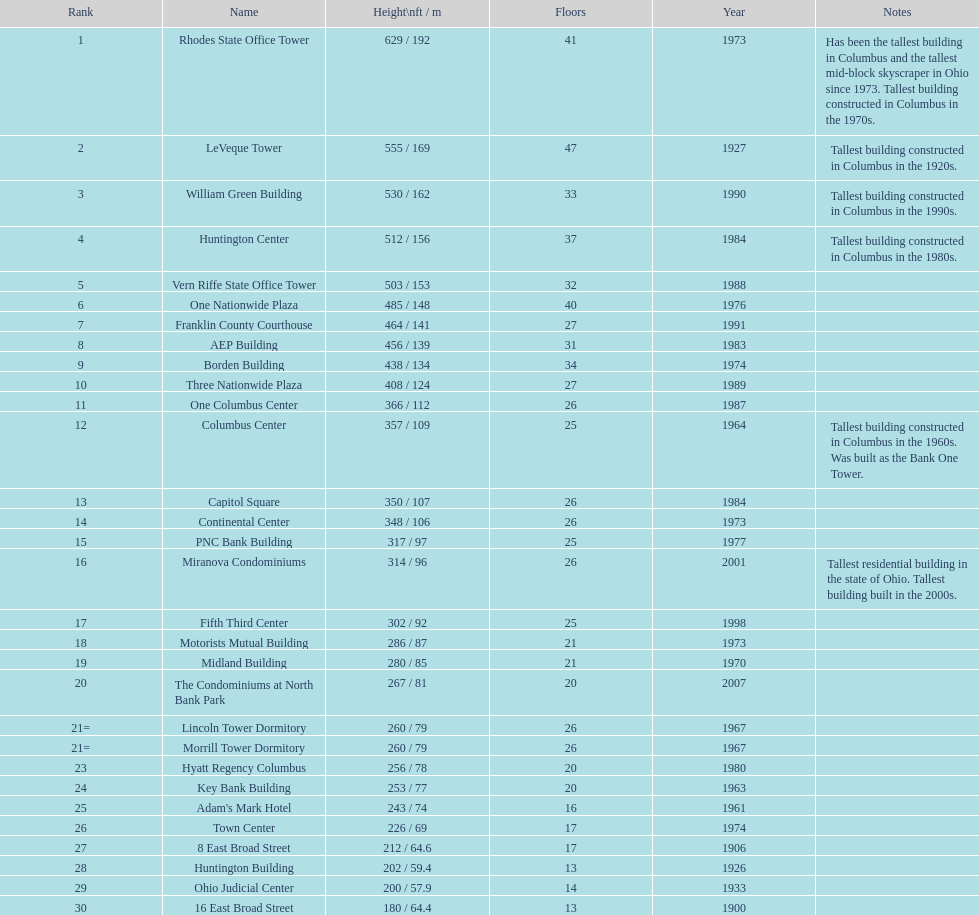How many levels does the leveque tower contain? 47. 